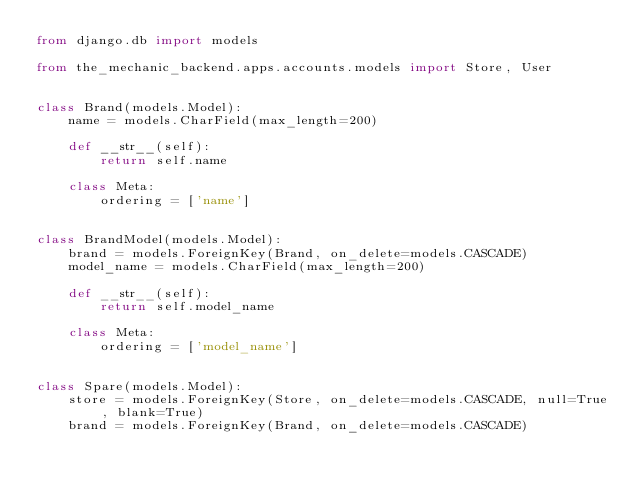<code> <loc_0><loc_0><loc_500><loc_500><_Python_>from django.db import models

from the_mechanic_backend.apps.accounts.models import Store, User


class Brand(models.Model):
    name = models.CharField(max_length=200)

    def __str__(self):
        return self.name

    class Meta:
        ordering = ['name']


class BrandModel(models.Model):
    brand = models.ForeignKey(Brand, on_delete=models.CASCADE)
    model_name = models.CharField(max_length=200)

    def __str__(self):
        return self.model_name

    class Meta:
        ordering = ['model_name']


class Spare(models.Model):
    store = models.ForeignKey(Store, on_delete=models.CASCADE, null=True, blank=True)
    brand = models.ForeignKey(Brand, on_delete=models.CASCADE)</code> 